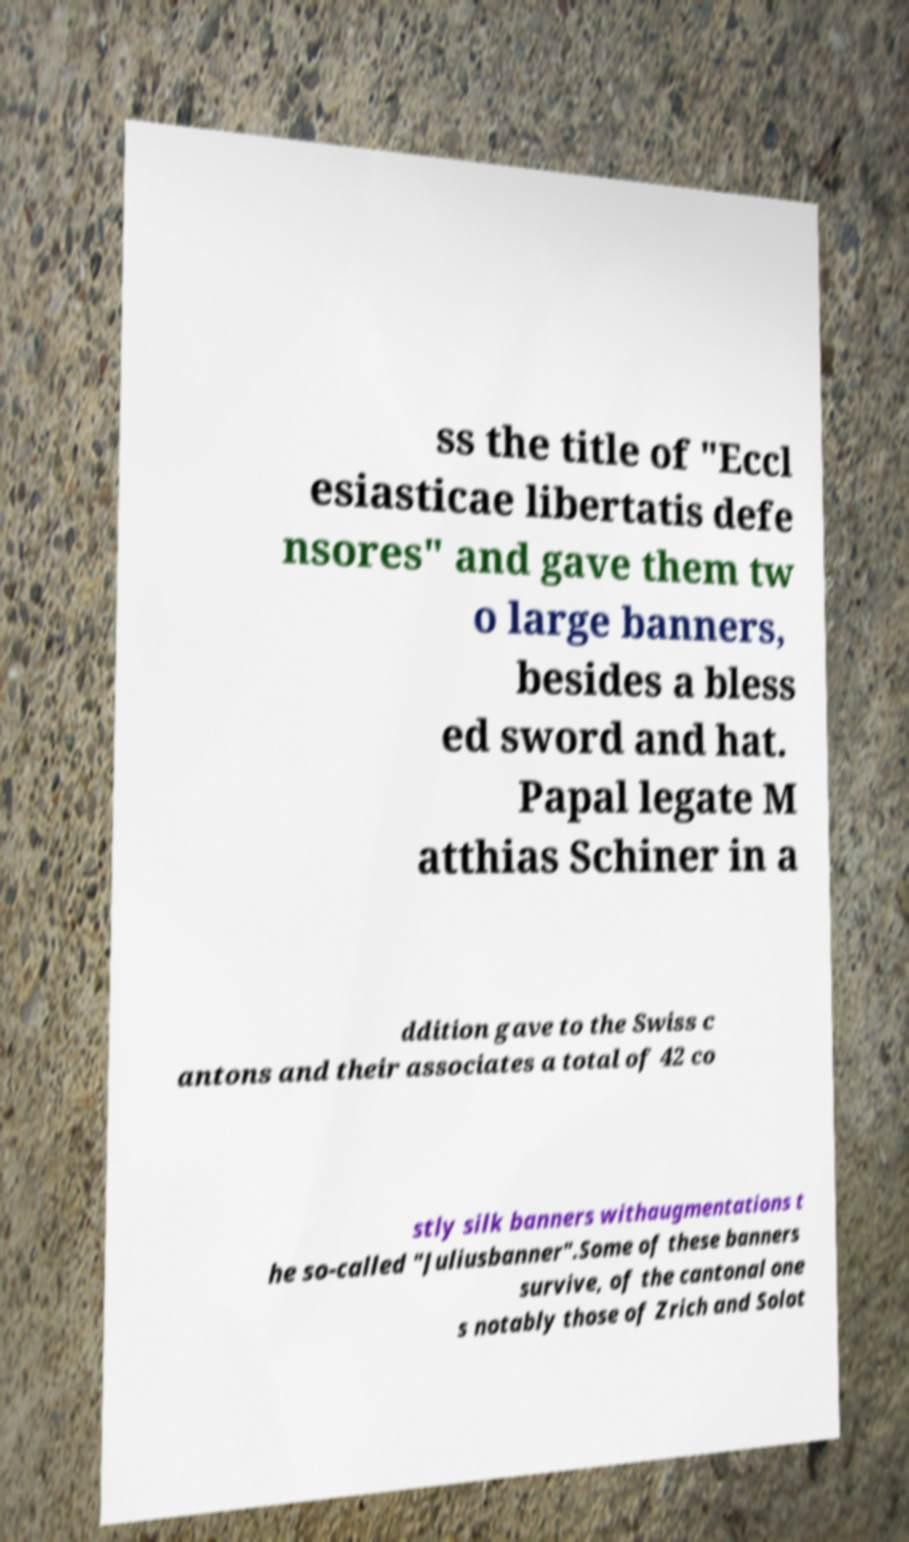Can you accurately transcribe the text from the provided image for me? ss the title of "Eccl esiasticae libertatis defe nsores" and gave them tw o large banners, besides a bless ed sword and hat. Papal legate M atthias Schiner in a ddition gave to the Swiss c antons and their associates a total of 42 co stly silk banners withaugmentations t he so-called "Juliusbanner".Some of these banners survive, of the cantonal one s notably those of Zrich and Solot 